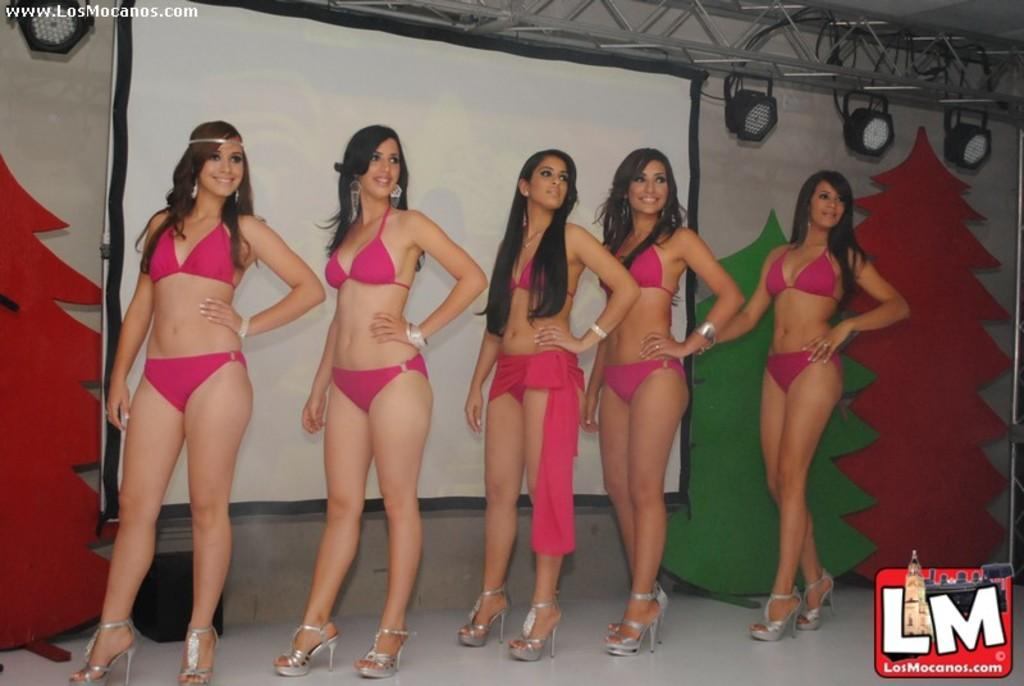What can be seen in the image regarding the people present? There are women standing in the image. Where are the women standing? The women are standing on the floor. What can be seen in the background of the image? There is a screen visible in the image. What type of equipment is present in the image? Focusing lights and rods are present in the image. What type of decorative elements are visible in the image? Decorative trees are visible in the image. What type of structure is present in the image? There is a wall in the image. What type of suit is the scarecrow wearing in the image? There is no scarecrow present in the image, and therefore no suit can be observed. What type of food is the cook preparing in the image? There is no cook or food preparation visible in the image. 